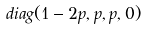<formula> <loc_0><loc_0><loc_500><loc_500>d i a g ( 1 - 2 p , p , p , 0 )</formula> 